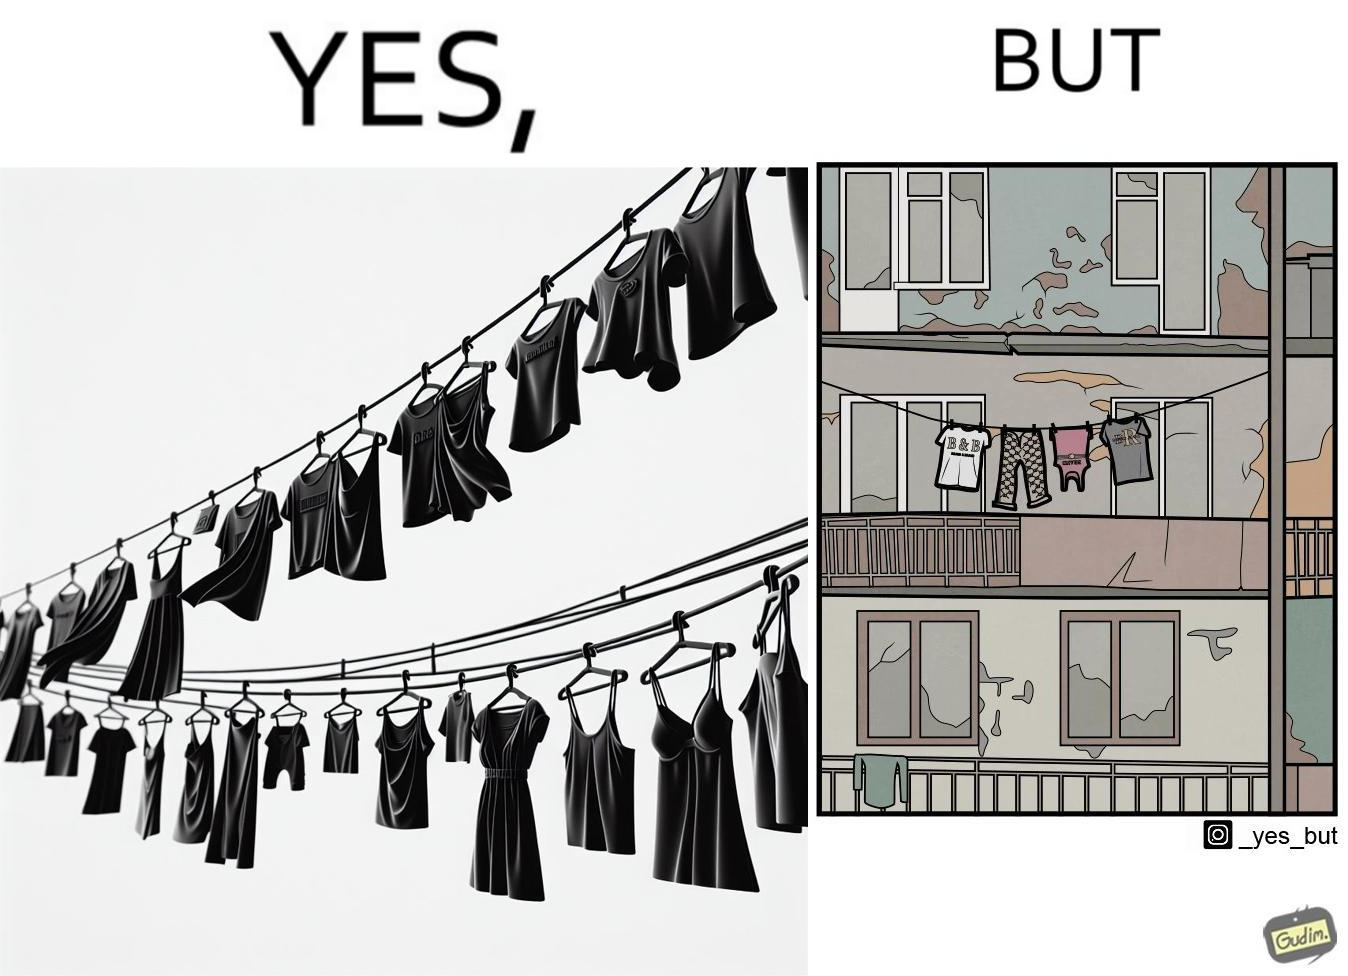What makes this image funny or satirical? The image is ironic because although the clothes are of branded companies but they are hanging in very poor building. 